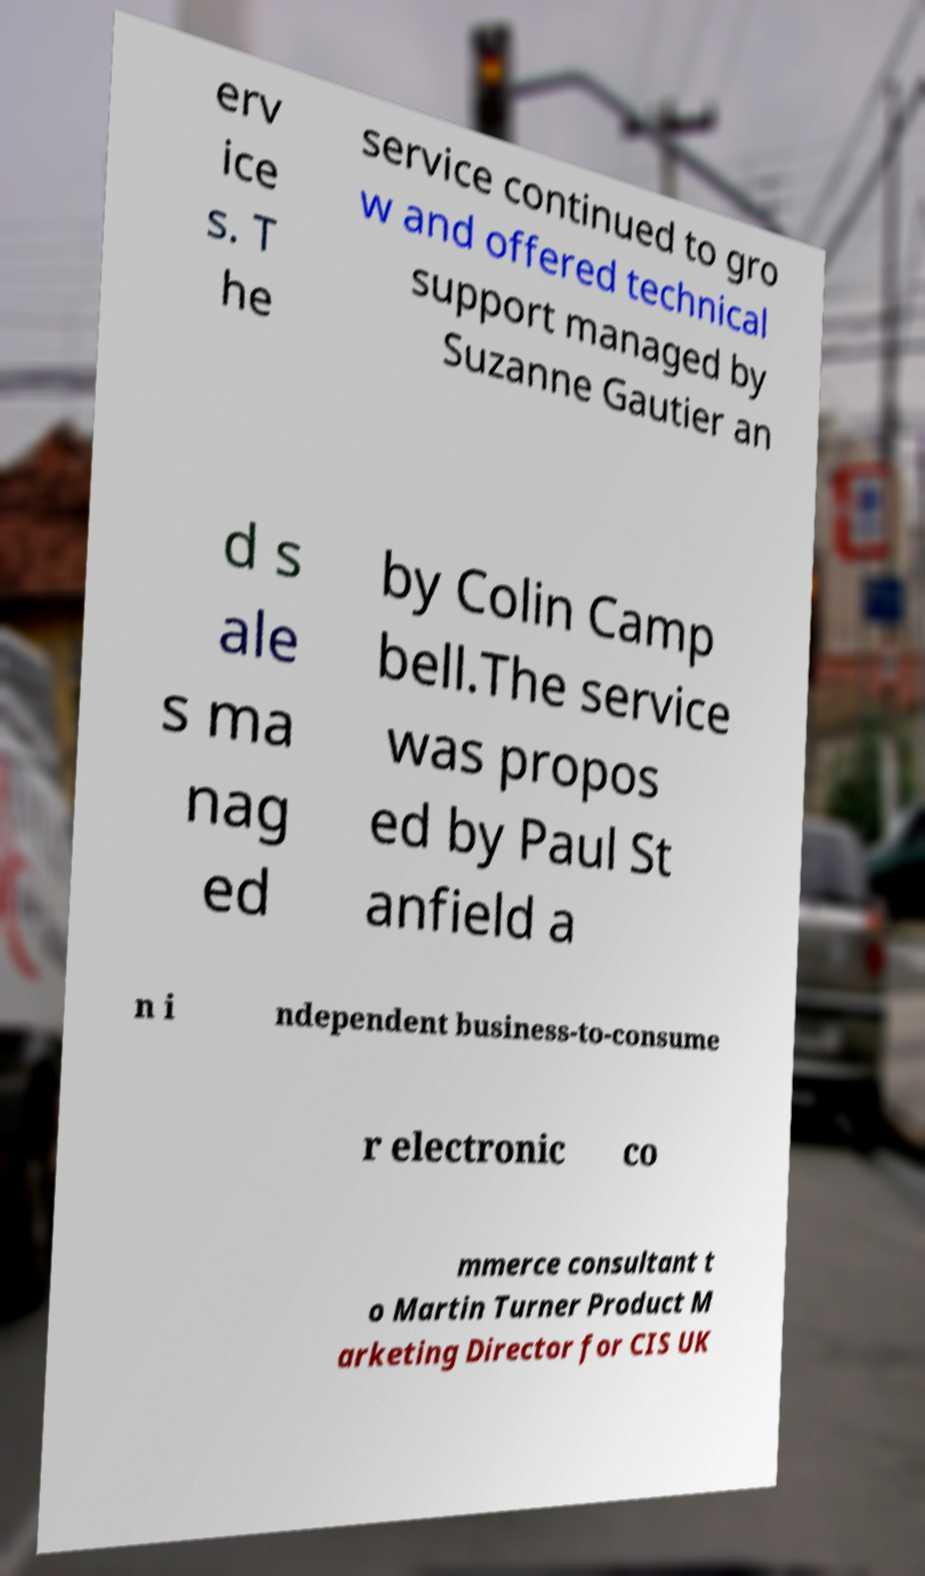What messages or text are displayed in this image? I need them in a readable, typed format. erv ice s. T he service continued to gro w and offered technical support managed by Suzanne Gautier an d s ale s ma nag ed by Colin Camp bell.The service was propos ed by Paul St anfield a n i ndependent business-to-consume r electronic co mmerce consultant t o Martin Turner Product M arketing Director for CIS UK 